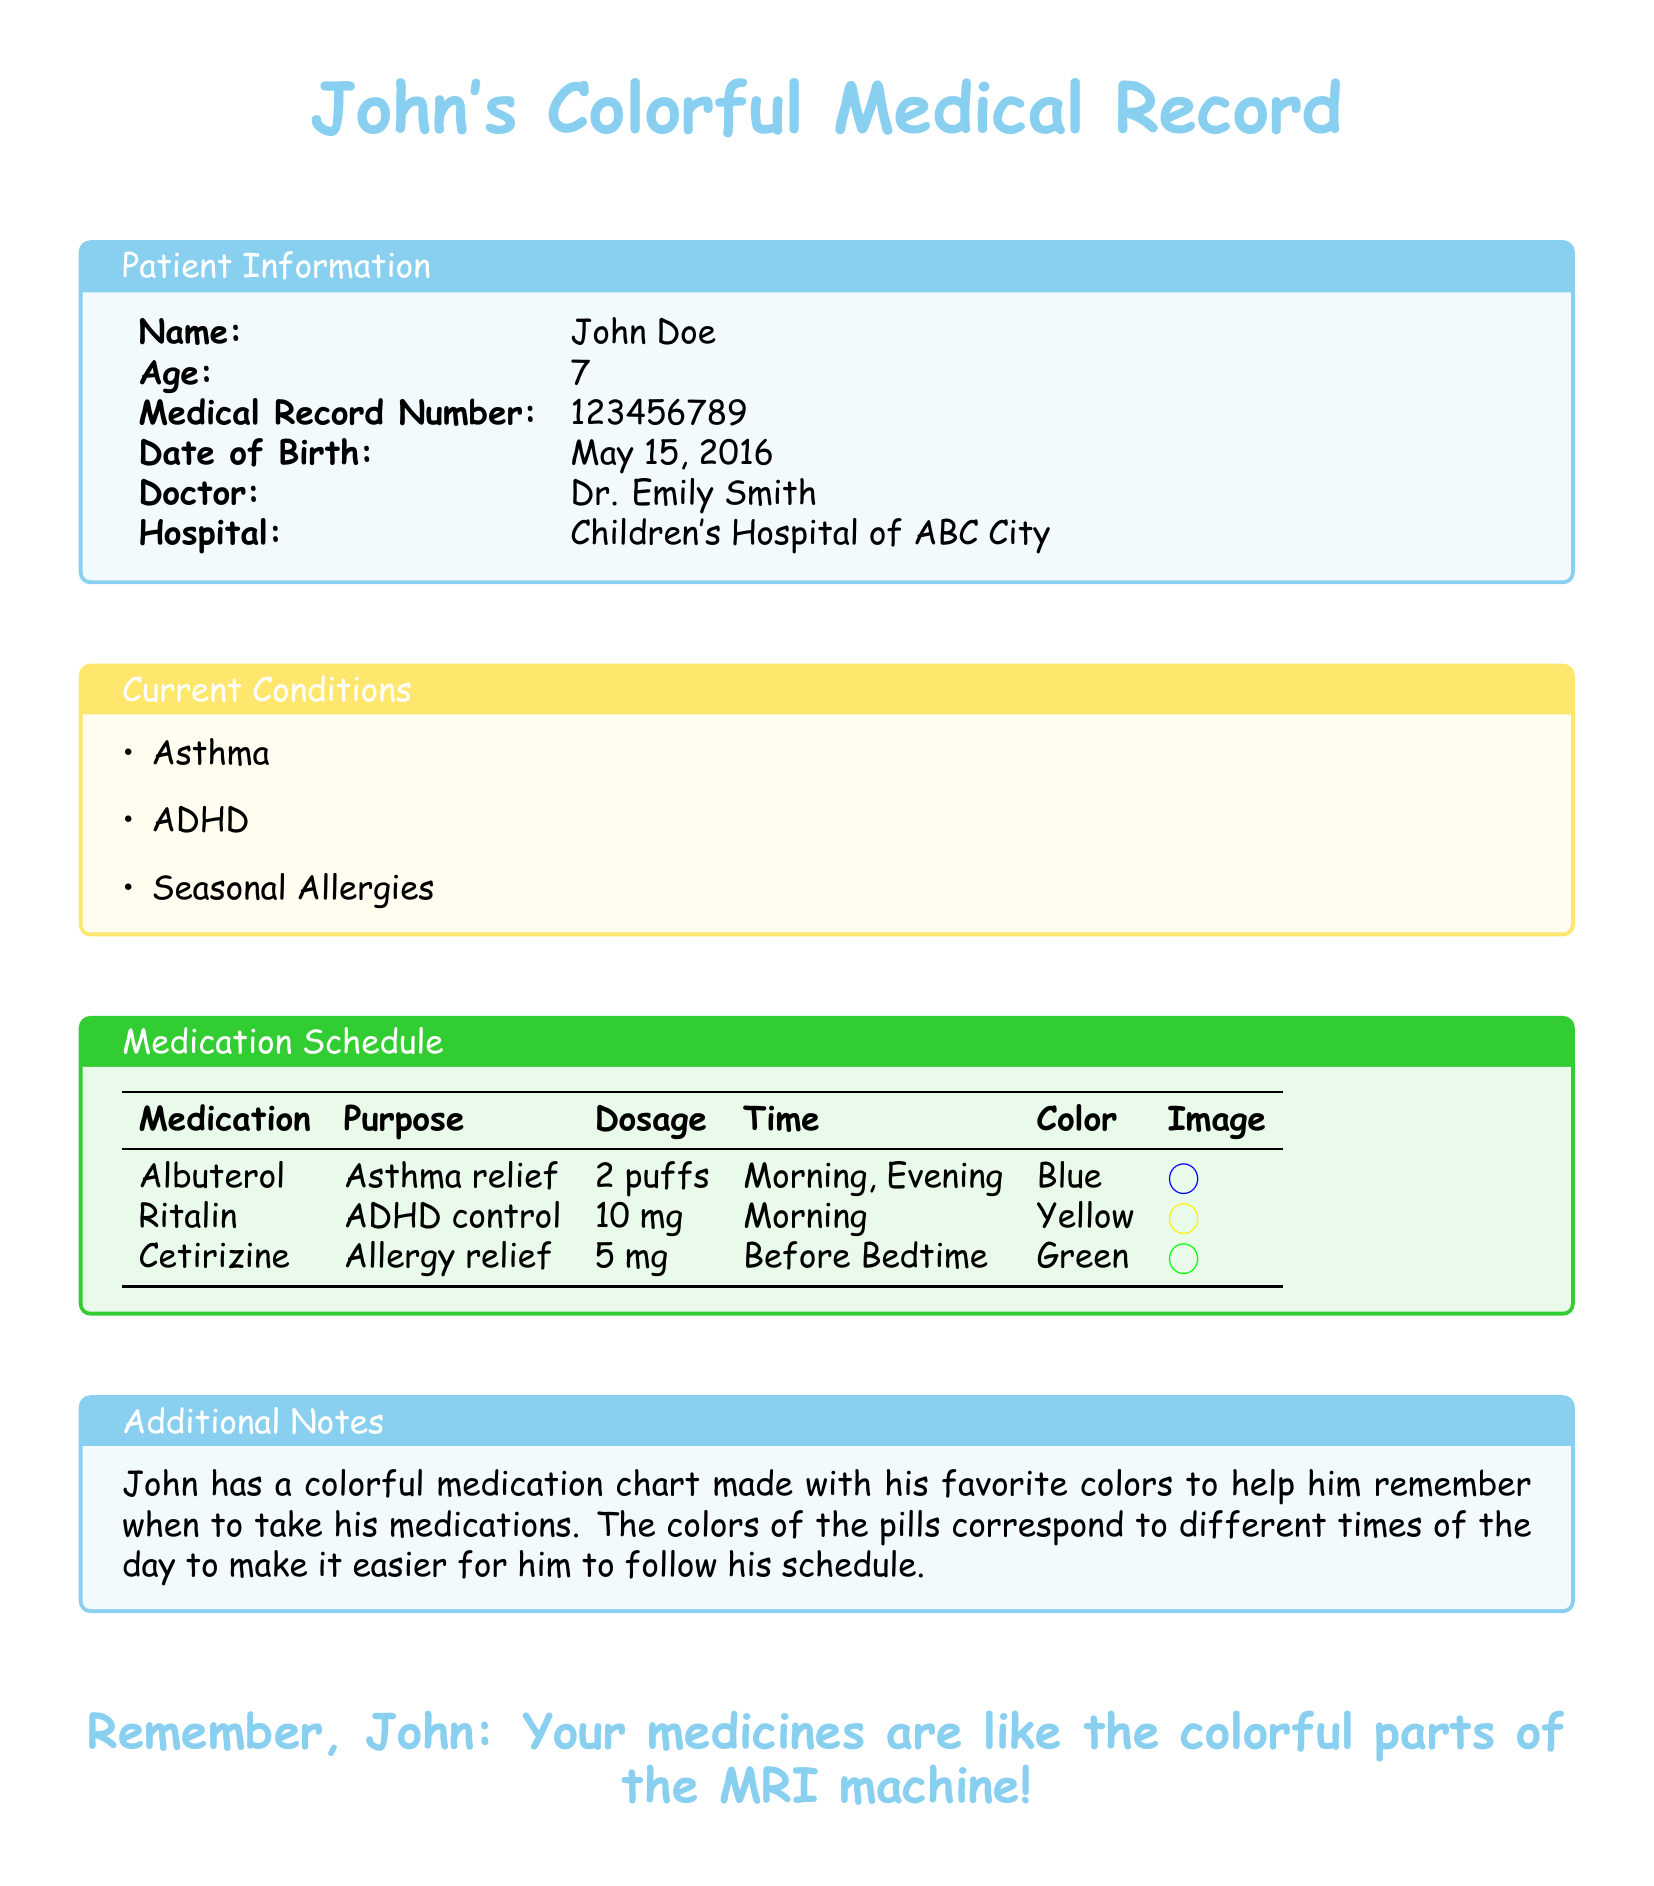What is John's age? John's age is listed in the patient information section of the document.
Answer: 7 What medication is used for asthma relief? The document provides a list of medications and their purposes, including Albuterol for asthma relief.
Answer: Albuterol What is the dosage of Ritalin? The dosage for Ritalin is specifically mentioned in the medication schedule section.
Answer: 10 mg At what time should John take Cetirizine? The document specifies the timing for taking Cetirizine under the medication schedule.
Answer: Before Bedtime What color represents the morning medication? The color coding for medications is included in the schedule, with specific colors for each.
Answer: Blue How many puffs of Albuterol does John take? The dosage for Albuterol is clearly stated in the document.
Answer: 2 puffs What is the purpose of Cetirizine? The purpose of each medication is listed next to the respective medication in the schedule.
Answer: Allergy relief Which doctor is listed in the document? The doctor's name is provided in the patient information section of the document.
Answer: Dr. Emily Smith What does the colorful medication chart help John remember? The additional notes explain that the chart helps John remember when to take his medications.
Answer: When to take his medications 